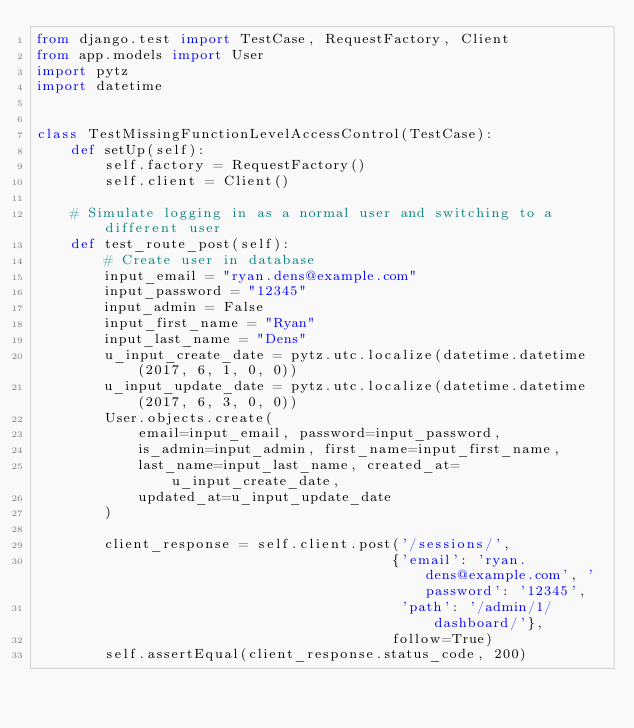<code> <loc_0><loc_0><loc_500><loc_500><_Python_>from django.test import TestCase, RequestFactory, Client
from app.models import User
import pytz
import datetime


class TestMissingFunctionLevelAccessControl(TestCase):
    def setUp(self):
        self.factory = RequestFactory()
        self.client = Client()

    # Simulate logging in as a normal user and switching to a different user
    def test_route_post(self):
        # Create user in database
        input_email = "ryan.dens@example.com"
        input_password = "12345"
        input_admin = False
        input_first_name = "Ryan"
        input_last_name = "Dens"
        u_input_create_date = pytz.utc.localize(datetime.datetime(2017, 6, 1, 0, 0))
        u_input_update_date = pytz.utc.localize(datetime.datetime(2017, 6, 3, 0, 0))
        User.objects.create(
            email=input_email, password=input_password,
            is_admin=input_admin, first_name=input_first_name,
            last_name=input_last_name, created_at=u_input_create_date,
            updated_at=u_input_update_date
        )

        client_response = self.client.post('/sessions/',
                                          {'email': 'ryan.dens@example.com', 'password': '12345',
                                           'path': '/admin/1/dashboard/'},
                                          follow=True)
        self.assertEqual(client_response.status_code, 200)
</code> 